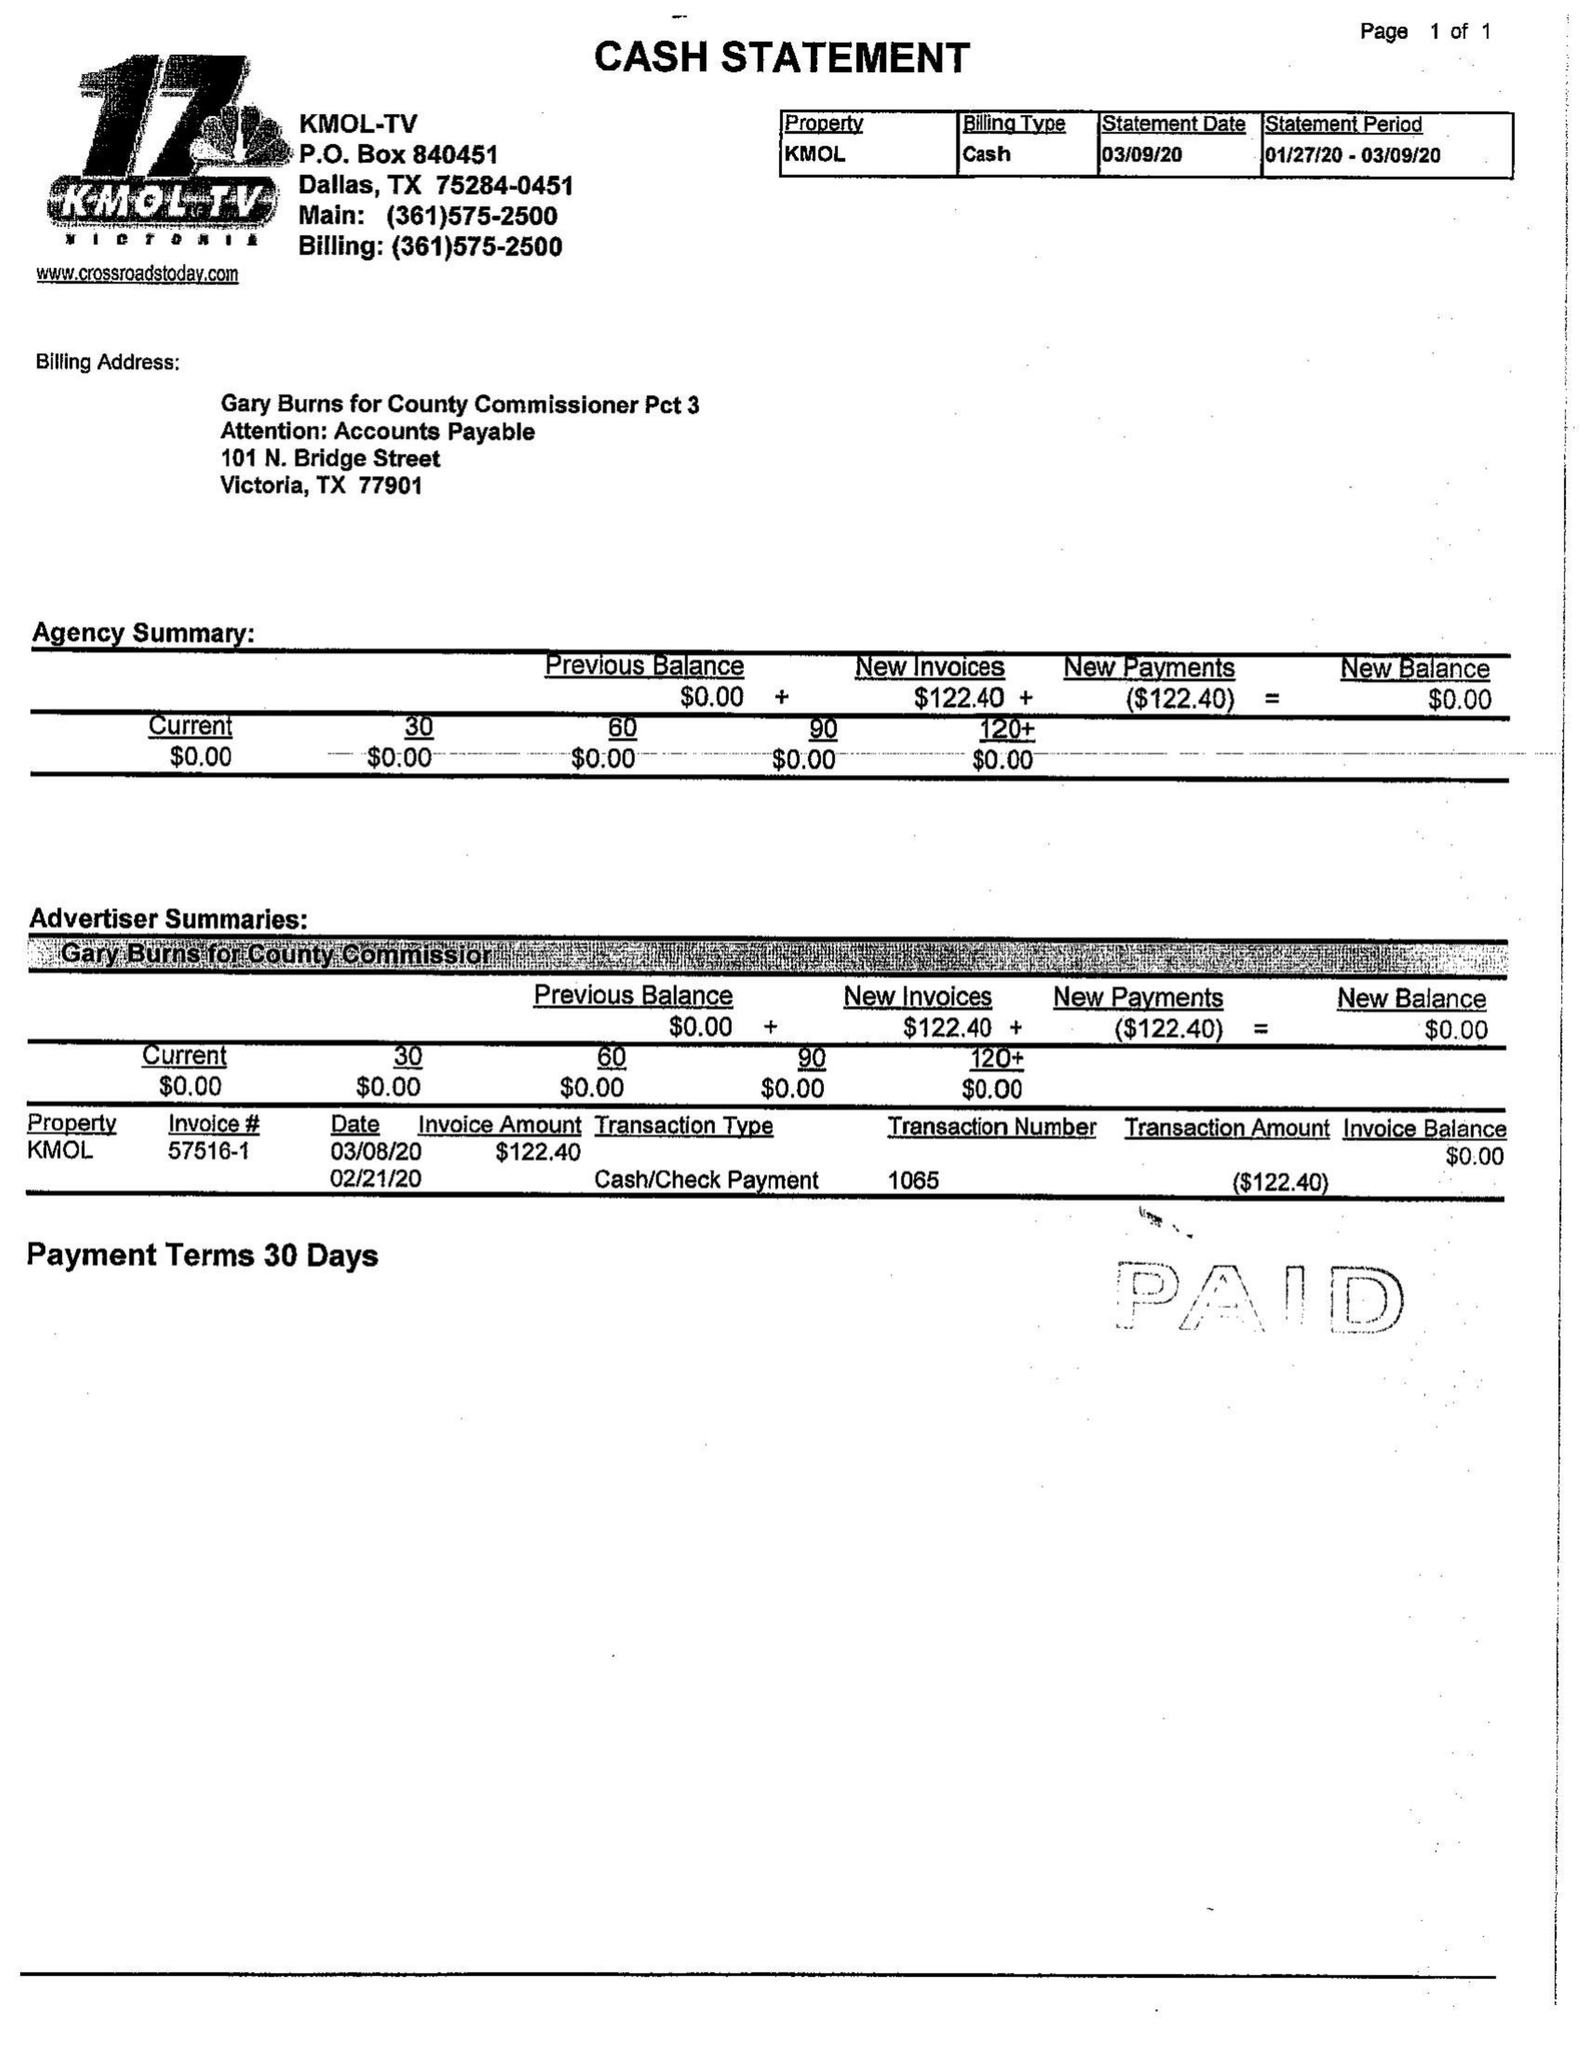What is the value for the contract_num?
Answer the question using a single word or phrase. 5716 